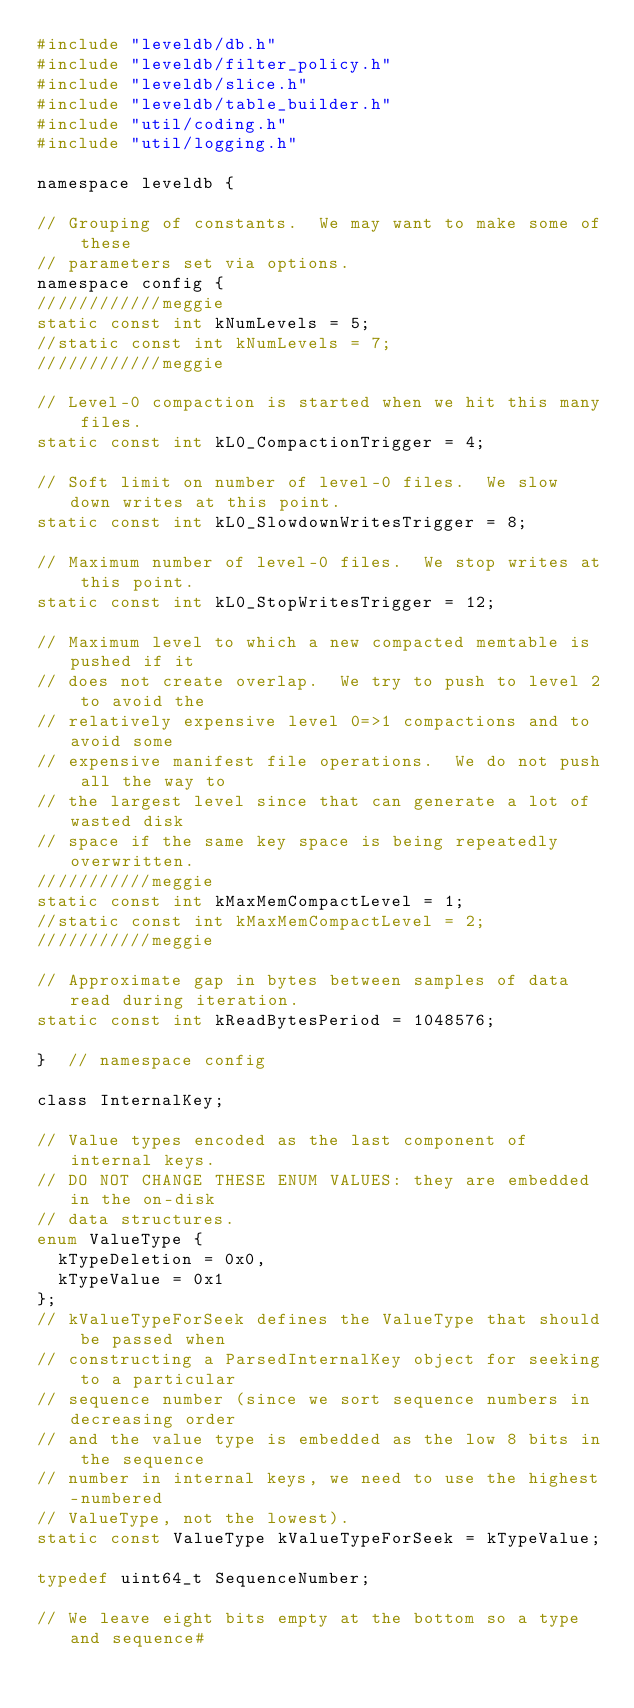<code> <loc_0><loc_0><loc_500><loc_500><_C_>#include "leveldb/db.h"
#include "leveldb/filter_policy.h"
#include "leveldb/slice.h"
#include "leveldb/table_builder.h"
#include "util/coding.h"
#include "util/logging.h"

namespace leveldb {

// Grouping of constants.  We may want to make some of these
// parameters set via options.
namespace config {
////////////meggie
static const int kNumLevels = 5;
//static const int kNumLevels = 7;
////////////meggie

// Level-0 compaction is started when we hit this many files.
static const int kL0_CompactionTrigger = 4;

// Soft limit on number of level-0 files.  We slow down writes at this point.
static const int kL0_SlowdownWritesTrigger = 8;

// Maximum number of level-0 files.  We stop writes at this point.
static const int kL0_StopWritesTrigger = 12;

// Maximum level to which a new compacted memtable is pushed if it
// does not create overlap.  We try to push to level 2 to avoid the
// relatively expensive level 0=>1 compactions and to avoid some
// expensive manifest file operations.  We do not push all the way to
// the largest level since that can generate a lot of wasted disk
// space if the same key space is being repeatedly overwritten.
///////////meggie
static const int kMaxMemCompactLevel = 1;
//static const int kMaxMemCompactLevel = 2;
///////////meggie

// Approximate gap in bytes between samples of data read during iteration.
static const int kReadBytesPeriod = 1048576;

}  // namespace config

class InternalKey;

// Value types encoded as the last component of internal keys.
// DO NOT CHANGE THESE ENUM VALUES: they are embedded in the on-disk
// data structures.
enum ValueType {
  kTypeDeletion = 0x0,
  kTypeValue = 0x1
};
// kValueTypeForSeek defines the ValueType that should be passed when
// constructing a ParsedInternalKey object for seeking to a particular
// sequence number (since we sort sequence numbers in decreasing order
// and the value type is embedded as the low 8 bits in the sequence
// number in internal keys, we need to use the highest-numbered
// ValueType, not the lowest).
static const ValueType kValueTypeForSeek = kTypeValue;

typedef uint64_t SequenceNumber;

// We leave eight bits empty at the bottom so a type and sequence#</code> 